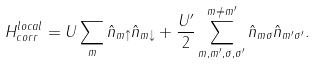Convert formula to latex. <formula><loc_0><loc_0><loc_500><loc_500>H ^ { l o c a l } _ { c o r r } = U \sum _ { m } \hat { n } _ { m \uparrow } \hat { n } _ { m \downarrow } + \frac { U ^ { \prime } } { 2 } \sum _ { m , m ^ { \prime } , \sigma , \sigma ^ { \prime } } ^ { m \ne m ^ { \prime } } \hat { n } _ { m \sigma } \hat { n } _ { m ^ { \prime } \sigma ^ { \prime } } .</formula> 